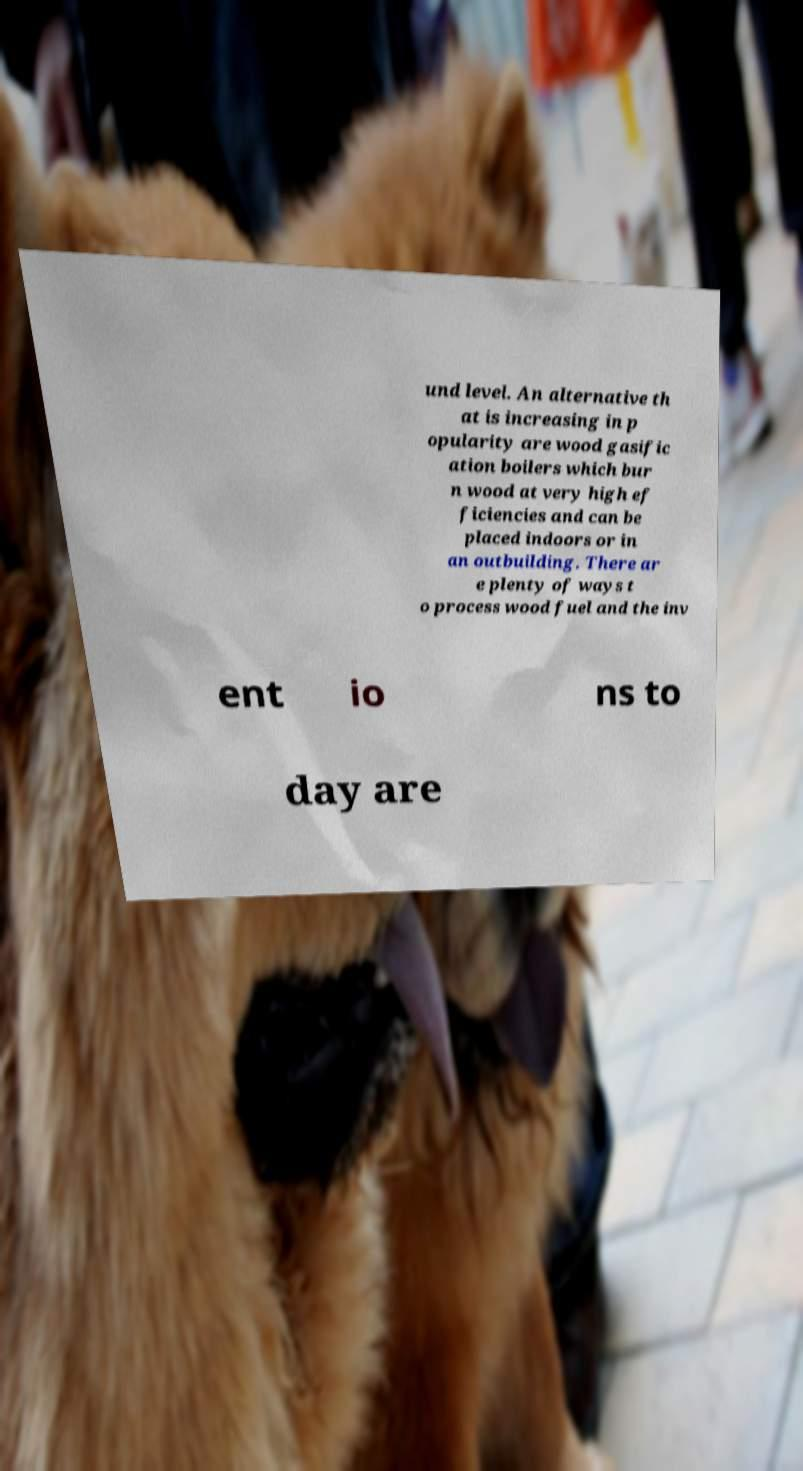For documentation purposes, I need the text within this image transcribed. Could you provide that? und level. An alternative th at is increasing in p opularity are wood gasific ation boilers which bur n wood at very high ef ficiencies and can be placed indoors or in an outbuilding. There ar e plenty of ways t o process wood fuel and the inv ent io ns to day are 